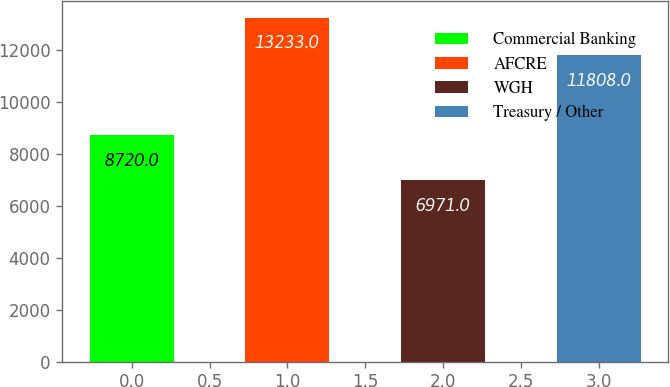Convert chart to OTSL. <chart><loc_0><loc_0><loc_500><loc_500><bar_chart><fcel>Commercial Banking<fcel>AFCRE<fcel>WGH<fcel>Treasury / Other<nl><fcel>8720<fcel>13233<fcel>6971<fcel>11808<nl></chart> 